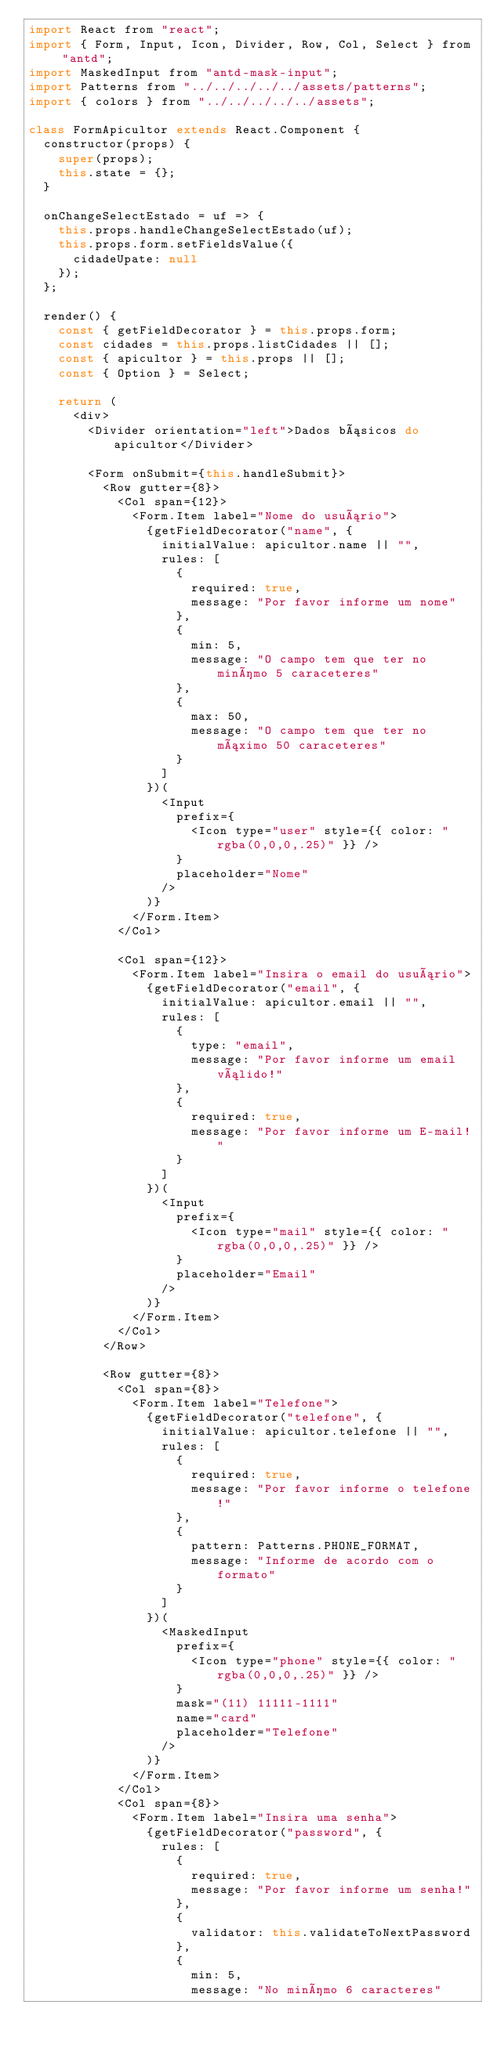<code> <loc_0><loc_0><loc_500><loc_500><_JavaScript_>import React from "react";
import { Form, Input, Icon, Divider, Row, Col, Select } from "antd";
import MaskedInput from "antd-mask-input";
import Patterns from "../../../../../assets/patterns";
import { colors } from "../../../../../assets";

class FormApicultor extends React.Component {
  constructor(props) {
    super(props);
    this.state = {};
  }

  onChangeSelectEstado = uf => {
    this.props.handleChangeSelectEstado(uf);
    this.props.form.setFieldsValue({
      cidadeUpate: null
    });
  };

  render() {
    const { getFieldDecorator } = this.props.form;
    const cidades = this.props.listCidades || [];
    const { apicultor } = this.props || [];
    const { Option } = Select;

    return (
      <div>
        <Divider orientation="left">Dados básicos do apicultor</Divider>

        <Form onSubmit={this.handleSubmit}>
          <Row gutter={8}>
            <Col span={12}>
              <Form.Item label="Nome do usuário">
                {getFieldDecorator("name", {
                  initialValue: apicultor.name || "",
                  rules: [
                    {
                      required: true,
                      message: "Por favor informe um nome"
                    },
                    {
                      min: 5,
                      message: "O campo tem que ter no minímo 5 caraceteres"
                    },
                    {
                      max: 50,
                      message: "O campo tem que ter no máximo 50 caraceteres"
                    }
                  ]
                })(
                  <Input
                    prefix={
                      <Icon type="user" style={{ color: "rgba(0,0,0,.25)" }} />
                    }
                    placeholder="Nome"
                  />
                )}
              </Form.Item>
            </Col>

            <Col span={12}>
              <Form.Item label="Insira o email do usuário">
                {getFieldDecorator("email", {
                  initialValue: apicultor.email || "",
                  rules: [
                    {
                      type: "email",
                      message: "Por favor informe um email válido!"
                    },
                    {
                      required: true,
                      message: "Por favor informe um E-mail!"
                    }
                  ]
                })(
                  <Input
                    prefix={
                      <Icon type="mail" style={{ color: "rgba(0,0,0,.25)" }} />
                    }
                    placeholder="Email"
                  />
                )}
              </Form.Item>
            </Col>
          </Row>

          <Row gutter={8}>
            <Col span={8}>
              <Form.Item label="Telefone">
                {getFieldDecorator("telefone", {
                  initialValue: apicultor.telefone || "",
                  rules: [
                    {
                      required: true,
                      message: "Por favor informe o telefone!"
                    },
                    {
                      pattern: Patterns.PHONE_FORMAT,
                      message: "Informe de acordo com o formato"
                    }
                  ]
                })(
                  <MaskedInput
                    prefix={
                      <Icon type="phone" style={{ color: "rgba(0,0,0,.25)" }} />
                    }
                    mask="(11) 11111-1111"
                    name="card"
                    placeholder="Telefone"
                  />
                )}
              </Form.Item>
            </Col>
            <Col span={8}>
              <Form.Item label="Insira uma senha">
                {getFieldDecorator("password", {
                  rules: [
                    {
                      required: true,
                      message: "Por favor informe um senha!"
                    },
                    {
                      validator: this.validateToNextPassword
                    },
                    {
                      min: 5,
                      message: "No minímo 6 caracteres"</code> 